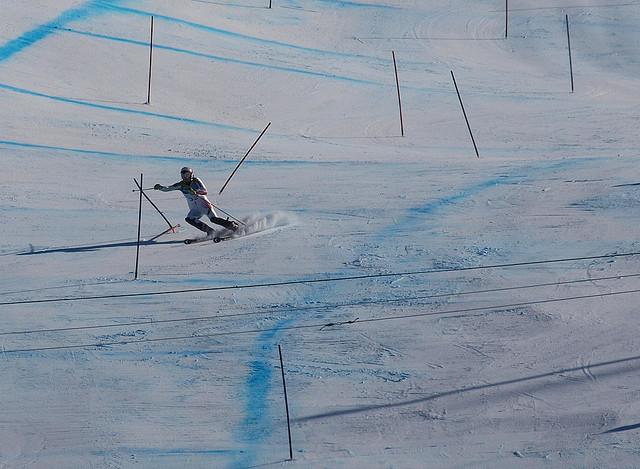Is it currently snowing in the scene?
Give a very brief answer. No. How many poles are in the picture?
Quick response, please. 10. Is the photo colored?
Concise answer only. Yes. What are the blue lines?
Be succinct. Boundaries. 